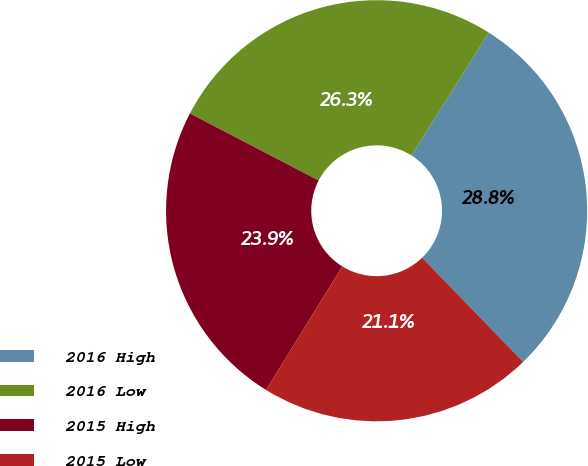<chart> <loc_0><loc_0><loc_500><loc_500><pie_chart><fcel>2016 High<fcel>2016 Low<fcel>2015 High<fcel>2015 Low<nl><fcel>28.8%<fcel>26.29%<fcel>23.85%<fcel>21.05%<nl></chart> 